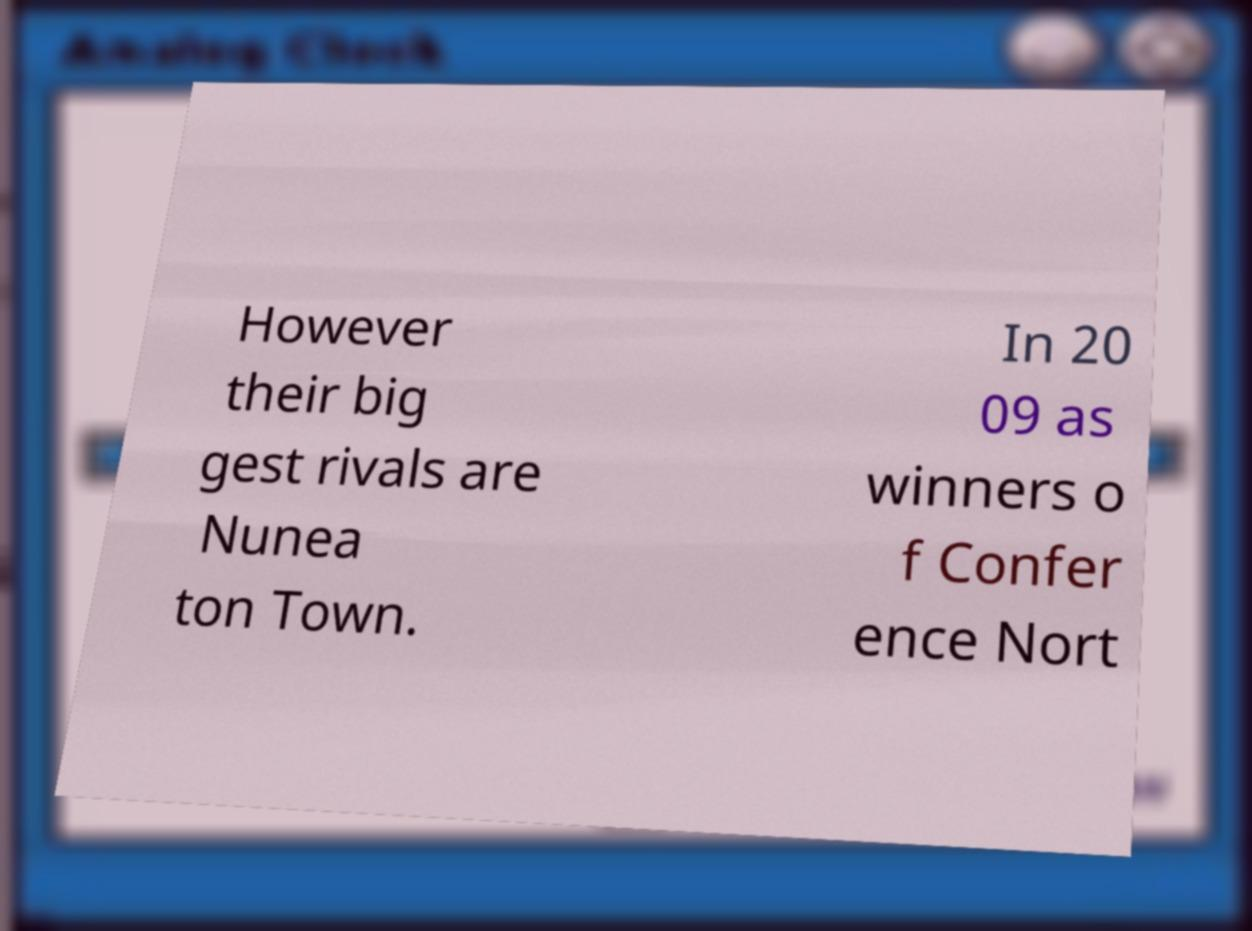I need the written content from this picture converted into text. Can you do that? However their big gest rivals are Nunea ton Town. In 20 09 as winners o f Confer ence Nort 